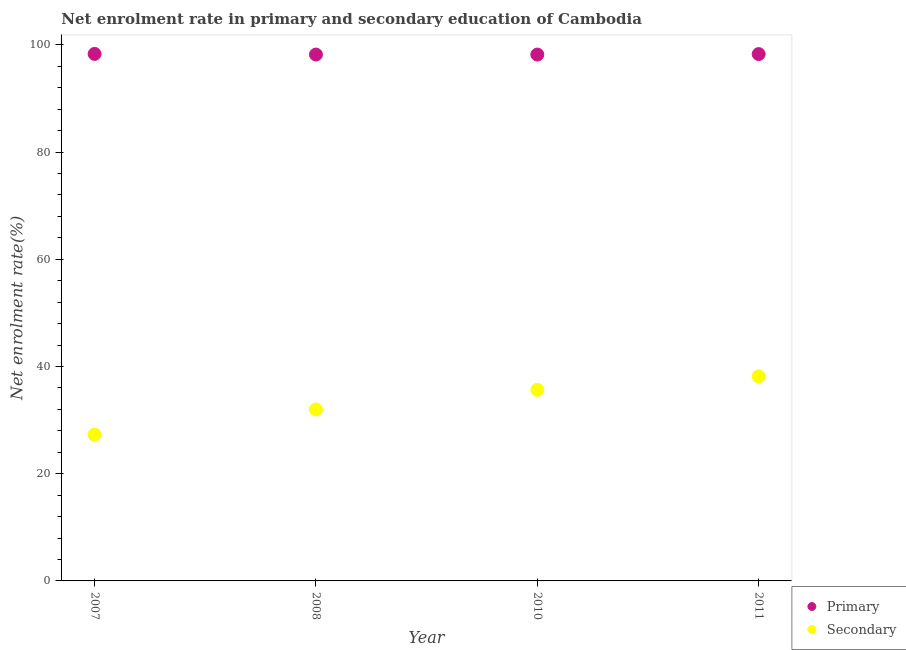How many different coloured dotlines are there?
Ensure brevity in your answer.  2. What is the enrollment rate in secondary education in 2007?
Provide a short and direct response. 27.29. Across all years, what is the maximum enrollment rate in secondary education?
Offer a very short reply. 38.15. Across all years, what is the minimum enrollment rate in secondary education?
Your answer should be compact. 27.29. In which year was the enrollment rate in primary education maximum?
Your response must be concise. 2007. What is the total enrollment rate in secondary education in the graph?
Offer a terse response. 133.08. What is the difference between the enrollment rate in secondary education in 2007 and that in 2011?
Your response must be concise. -10.86. What is the difference between the enrollment rate in primary education in 2011 and the enrollment rate in secondary education in 2007?
Your answer should be very brief. 70.99. What is the average enrollment rate in secondary education per year?
Offer a very short reply. 33.27. In the year 2008, what is the difference between the enrollment rate in secondary education and enrollment rate in primary education?
Your answer should be very brief. -66.21. In how many years, is the enrollment rate in primary education greater than 56 %?
Provide a short and direct response. 4. What is the ratio of the enrollment rate in primary education in 2010 to that in 2011?
Give a very brief answer. 1. What is the difference between the highest and the second highest enrollment rate in primary education?
Provide a succinct answer. 0.03. What is the difference between the highest and the lowest enrollment rate in secondary education?
Give a very brief answer. 10.86. How many years are there in the graph?
Your answer should be very brief. 4. Are the values on the major ticks of Y-axis written in scientific E-notation?
Make the answer very short. No. Does the graph contain any zero values?
Make the answer very short. No. Does the graph contain grids?
Offer a very short reply. No. Where does the legend appear in the graph?
Provide a succinct answer. Bottom right. What is the title of the graph?
Ensure brevity in your answer.  Net enrolment rate in primary and secondary education of Cambodia. Does "Services" appear as one of the legend labels in the graph?
Make the answer very short. No. What is the label or title of the X-axis?
Ensure brevity in your answer.  Year. What is the label or title of the Y-axis?
Your answer should be very brief. Net enrolment rate(%). What is the Net enrolment rate(%) in Primary in 2007?
Provide a short and direct response. 98.31. What is the Net enrolment rate(%) in Secondary in 2007?
Offer a very short reply. 27.29. What is the Net enrolment rate(%) of Primary in 2008?
Offer a terse response. 98.2. What is the Net enrolment rate(%) of Secondary in 2008?
Offer a terse response. 31.98. What is the Net enrolment rate(%) of Primary in 2010?
Make the answer very short. 98.19. What is the Net enrolment rate(%) in Secondary in 2010?
Offer a very short reply. 35.65. What is the Net enrolment rate(%) of Primary in 2011?
Your answer should be compact. 98.28. What is the Net enrolment rate(%) in Secondary in 2011?
Provide a succinct answer. 38.15. Across all years, what is the maximum Net enrolment rate(%) of Primary?
Make the answer very short. 98.31. Across all years, what is the maximum Net enrolment rate(%) of Secondary?
Give a very brief answer. 38.15. Across all years, what is the minimum Net enrolment rate(%) in Primary?
Your answer should be very brief. 98.19. Across all years, what is the minimum Net enrolment rate(%) in Secondary?
Your answer should be very brief. 27.29. What is the total Net enrolment rate(%) of Primary in the graph?
Ensure brevity in your answer.  392.99. What is the total Net enrolment rate(%) of Secondary in the graph?
Offer a very short reply. 133.08. What is the difference between the Net enrolment rate(%) in Primary in 2007 and that in 2008?
Provide a succinct answer. 0.12. What is the difference between the Net enrolment rate(%) of Secondary in 2007 and that in 2008?
Provide a short and direct response. -4.69. What is the difference between the Net enrolment rate(%) in Primary in 2007 and that in 2010?
Your answer should be very brief. 0.12. What is the difference between the Net enrolment rate(%) in Secondary in 2007 and that in 2010?
Your response must be concise. -8.35. What is the difference between the Net enrolment rate(%) of Primary in 2007 and that in 2011?
Make the answer very short. 0.03. What is the difference between the Net enrolment rate(%) of Secondary in 2007 and that in 2011?
Provide a succinct answer. -10.86. What is the difference between the Net enrolment rate(%) in Primary in 2008 and that in 2010?
Provide a succinct answer. 0. What is the difference between the Net enrolment rate(%) in Secondary in 2008 and that in 2010?
Give a very brief answer. -3.66. What is the difference between the Net enrolment rate(%) of Primary in 2008 and that in 2011?
Keep it short and to the point. -0.09. What is the difference between the Net enrolment rate(%) in Secondary in 2008 and that in 2011?
Ensure brevity in your answer.  -6.17. What is the difference between the Net enrolment rate(%) of Primary in 2010 and that in 2011?
Provide a succinct answer. -0.09. What is the difference between the Net enrolment rate(%) of Secondary in 2010 and that in 2011?
Offer a very short reply. -2.51. What is the difference between the Net enrolment rate(%) of Primary in 2007 and the Net enrolment rate(%) of Secondary in 2008?
Your answer should be very brief. 66.33. What is the difference between the Net enrolment rate(%) of Primary in 2007 and the Net enrolment rate(%) of Secondary in 2010?
Make the answer very short. 62.67. What is the difference between the Net enrolment rate(%) in Primary in 2007 and the Net enrolment rate(%) in Secondary in 2011?
Offer a very short reply. 60.16. What is the difference between the Net enrolment rate(%) in Primary in 2008 and the Net enrolment rate(%) in Secondary in 2010?
Provide a succinct answer. 62.55. What is the difference between the Net enrolment rate(%) of Primary in 2008 and the Net enrolment rate(%) of Secondary in 2011?
Keep it short and to the point. 60.04. What is the difference between the Net enrolment rate(%) in Primary in 2010 and the Net enrolment rate(%) in Secondary in 2011?
Provide a succinct answer. 60.04. What is the average Net enrolment rate(%) of Primary per year?
Ensure brevity in your answer.  98.25. What is the average Net enrolment rate(%) of Secondary per year?
Ensure brevity in your answer.  33.27. In the year 2007, what is the difference between the Net enrolment rate(%) of Primary and Net enrolment rate(%) of Secondary?
Offer a terse response. 71.02. In the year 2008, what is the difference between the Net enrolment rate(%) of Primary and Net enrolment rate(%) of Secondary?
Provide a short and direct response. 66.21. In the year 2010, what is the difference between the Net enrolment rate(%) of Primary and Net enrolment rate(%) of Secondary?
Provide a short and direct response. 62.55. In the year 2011, what is the difference between the Net enrolment rate(%) in Primary and Net enrolment rate(%) in Secondary?
Your answer should be compact. 60.13. What is the ratio of the Net enrolment rate(%) in Primary in 2007 to that in 2008?
Keep it short and to the point. 1. What is the ratio of the Net enrolment rate(%) in Secondary in 2007 to that in 2008?
Make the answer very short. 0.85. What is the ratio of the Net enrolment rate(%) in Secondary in 2007 to that in 2010?
Keep it short and to the point. 0.77. What is the ratio of the Net enrolment rate(%) of Secondary in 2007 to that in 2011?
Give a very brief answer. 0.72. What is the ratio of the Net enrolment rate(%) of Primary in 2008 to that in 2010?
Offer a very short reply. 1. What is the ratio of the Net enrolment rate(%) of Secondary in 2008 to that in 2010?
Keep it short and to the point. 0.9. What is the ratio of the Net enrolment rate(%) in Primary in 2008 to that in 2011?
Keep it short and to the point. 1. What is the ratio of the Net enrolment rate(%) of Secondary in 2008 to that in 2011?
Provide a succinct answer. 0.84. What is the ratio of the Net enrolment rate(%) of Primary in 2010 to that in 2011?
Your answer should be very brief. 1. What is the ratio of the Net enrolment rate(%) of Secondary in 2010 to that in 2011?
Your answer should be compact. 0.93. What is the difference between the highest and the second highest Net enrolment rate(%) of Primary?
Give a very brief answer. 0.03. What is the difference between the highest and the second highest Net enrolment rate(%) in Secondary?
Offer a very short reply. 2.51. What is the difference between the highest and the lowest Net enrolment rate(%) of Primary?
Your answer should be very brief. 0.12. What is the difference between the highest and the lowest Net enrolment rate(%) of Secondary?
Provide a succinct answer. 10.86. 